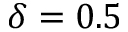Convert formula to latex. <formula><loc_0><loc_0><loc_500><loc_500>\delta = 0 . 5</formula> 